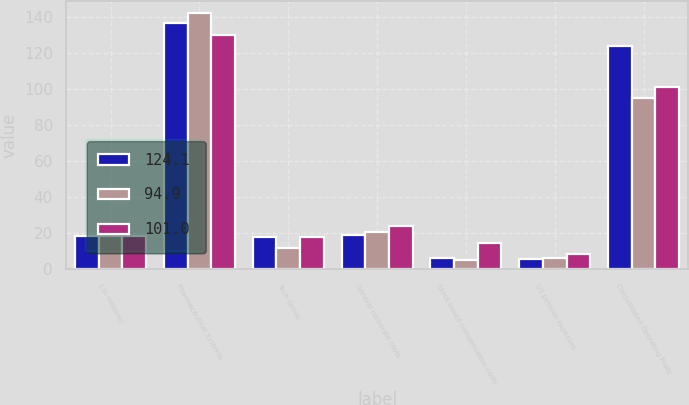Convert chart to OTSL. <chart><loc_0><loc_0><loc_500><loc_500><stacked_bar_chart><ecel><fcel>( in millions)<fcel>Pharmaceutical Systems<fcel>Tech Group<fcel>General corporate costs<fcel>Stock-based compensation costs<fcel>US pension expenses<fcel>Consolidated Operating Profit<nl><fcel>124.1<fcel>18.65<fcel>136.7<fcel>17.8<fcel>19.2<fcel>6.4<fcel>6<fcel>124.1<nl><fcel>94.9<fcel>18.65<fcel>141.9<fcel>11.6<fcel>21<fcel>5.1<fcel>6.1<fcel>94.9<nl><fcel>101<fcel>18.65<fcel>129.7<fcel>18.1<fcel>23.9<fcel>14.5<fcel>8.4<fcel>101<nl></chart> 